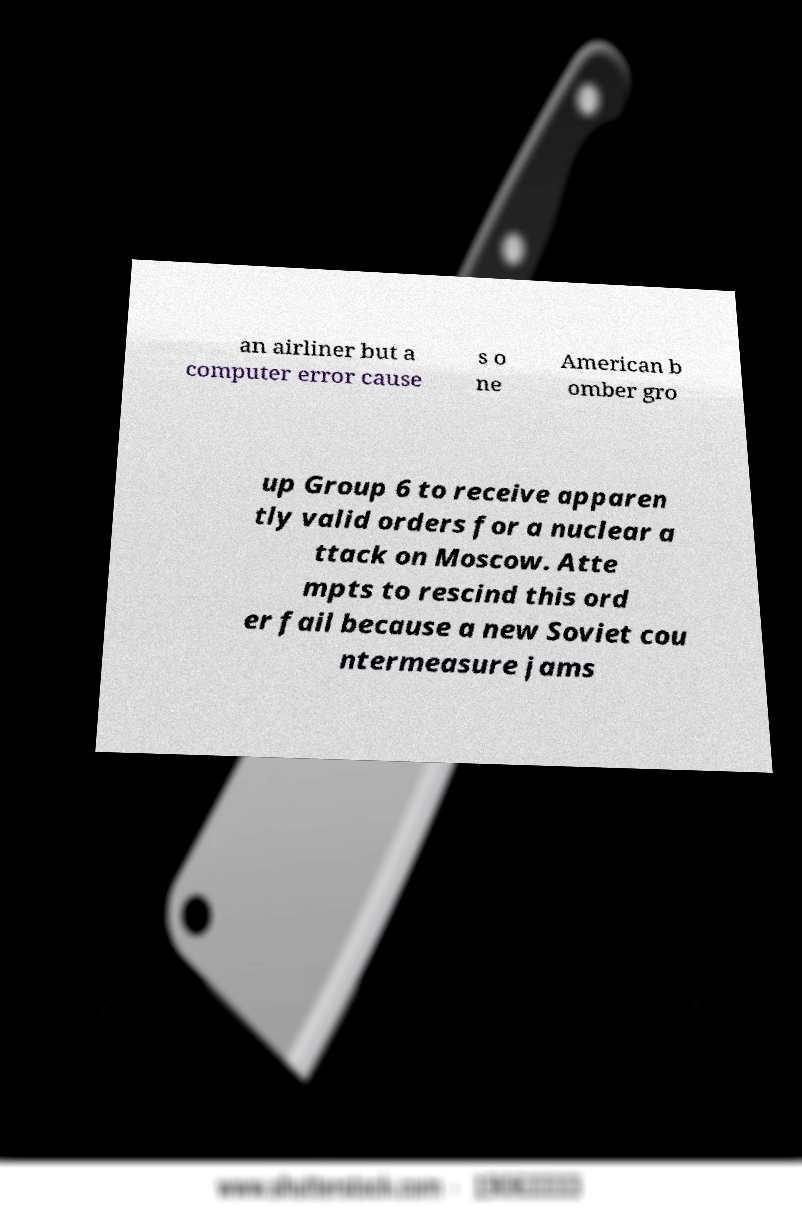There's text embedded in this image that I need extracted. Can you transcribe it verbatim? an airliner but a computer error cause s o ne American b omber gro up Group 6 to receive apparen tly valid orders for a nuclear a ttack on Moscow. Atte mpts to rescind this ord er fail because a new Soviet cou ntermeasure jams 